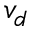<formula> <loc_0><loc_0><loc_500><loc_500>v _ { d }</formula> 